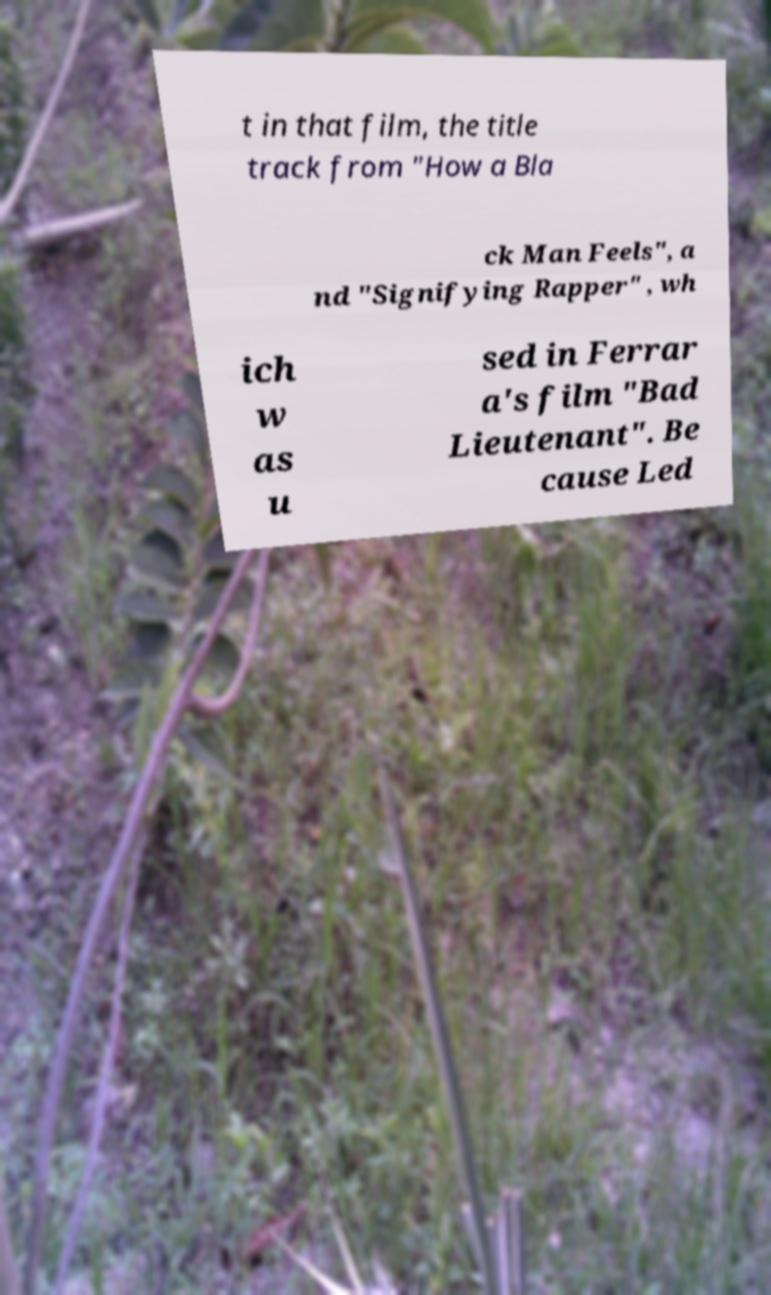Please read and relay the text visible in this image. What does it say? t in that film, the title track from "How a Bla ck Man Feels", a nd "Signifying Rapper" , wh ich w as u sed in Ferrar a's film "Bad Lieutenant". Be cause Led 